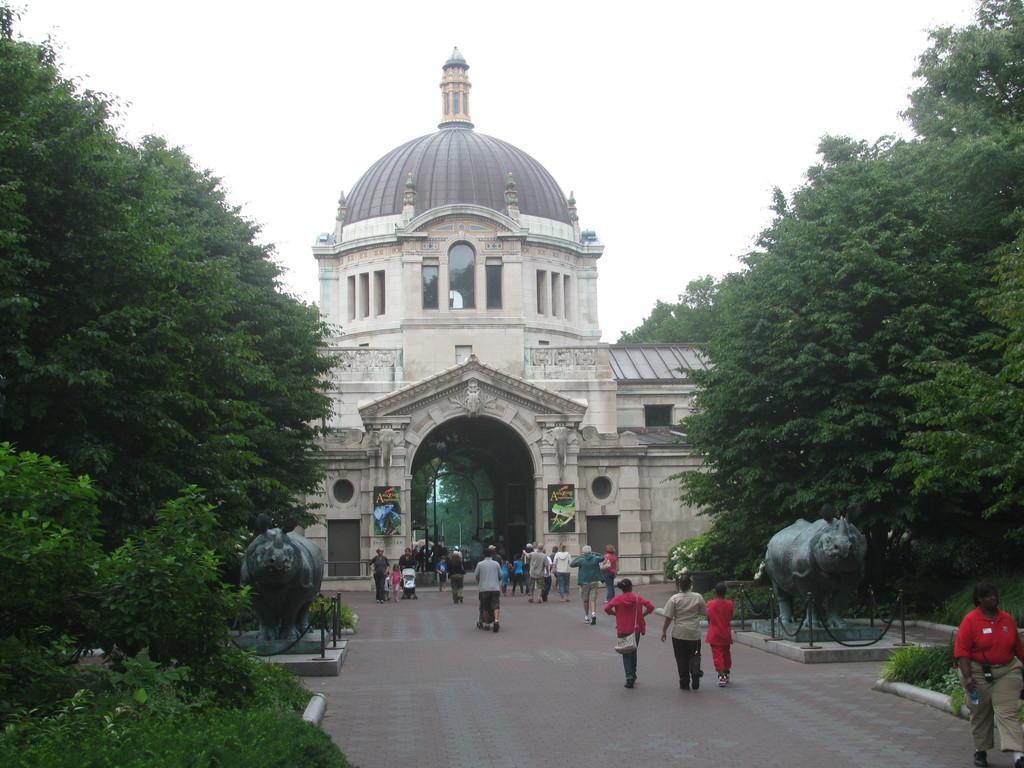Can you describe this image briefly? There is a road. There are many people walking on the road. On the sides there are statues and trees. In the back there is a building with arches, pillars. On the building there are posters. In the background there is sky. 